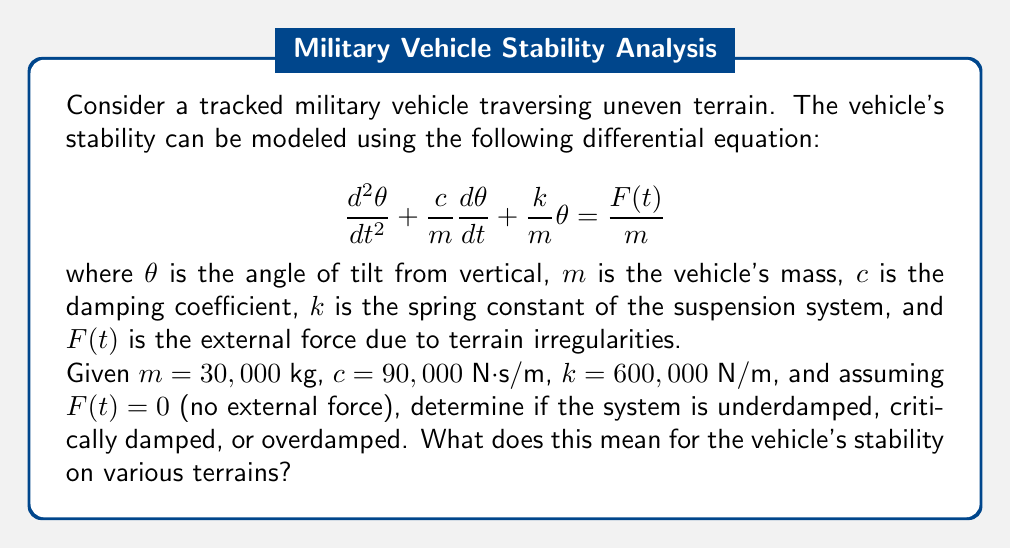Help me with this question. To analyze the stability of the tracked vehicle, we need to examine the characteristic equation of the given differential equation. The general form of the equation is:

$$\frac{d^2\theta}{dt^2} + 2\zeta\omega_n\frac{d\theta}{dt} + \omega_n^2\theta = \frac{F(t)}{m}$$

Where $\zeta$ is the damping ratio and $\omega_n$ is the natural frequency of the system.

Step 1: Identify $\omega_n$ and $2\zeta\omega_n$
$$\omega_n^2 = \frac{k}{m} = \frac{600,000}{30,000} = 20 \text{ rad}^2/\text{s}^2$$
$$\omega_n = \sqrt{20} \approx 4.47 \text{ rad/s}$$

$$2\zeta\omega_n = \frac{c}{m} = \frac{90,000}{30,000} = 3 \text{ s}^{-1}$$

Step 2: Calculate the damping ratio $\zeta$
$$\zeta = \frac{3}{2\omega_n} = \frac{3}{2(4.47)} \approx 0.336$$

Step 3: Determine the type of damping
The system is:
- Underdamped if $\zeta < 1$
- Critically damped if $\zeta = 1$
- Overdamped if $\zeta > 1$

Since $\zeta \approx 0.336 < 1$, the system is underdamped.

Step 4: Interpret the results
An underdamped system means that when disturbed, the vehicle will oscillate around its equilibrium position with decreasing amplitude over time. This indicates that the vehicle has good responsiveness to terrain changes but may experience some oscillations before stabilizing.

For military applications, this characteristic suggests:
1. The vehicle can quickly adapt to changing terrain, which is crucial for maneuverability in combat situations.
2. The suspension system provides enough damping to prevent excessive bouncing, ensuring a relatively smooth ride for personnel and equipment.
3. On rough terrains, the vehicle may experience some oscillations, but these will quickly diminish, maintaining overall stability.
4. The underdamped nature allows for better traction as the tracks maintain more consistent contact with the ground compared to an overdamped system.
Answer: The system is underdamped with a damping ratio $\zeta \approx 0.336$. This means the tracked vehicle will respond quickly to terrain changes with some oscillations that diminish over time, providing a balance between responsiveness and stability on various terrains. 